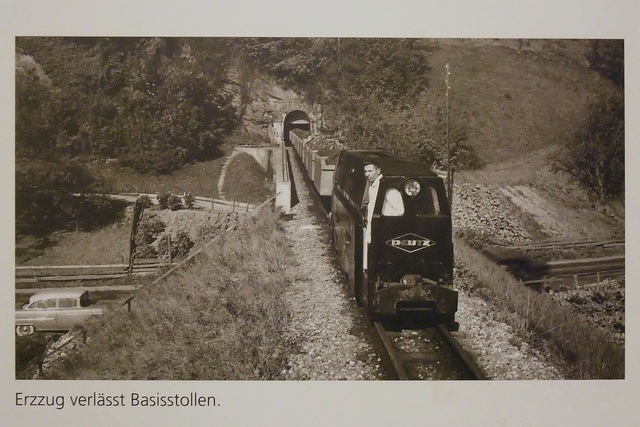Describe the objects in this image and their specific colors. I can see train in lightgray, black, and gray tones, people in lightgray, black, and gray tones, and car in lightgray, darkgray, and gray tones in this image. 